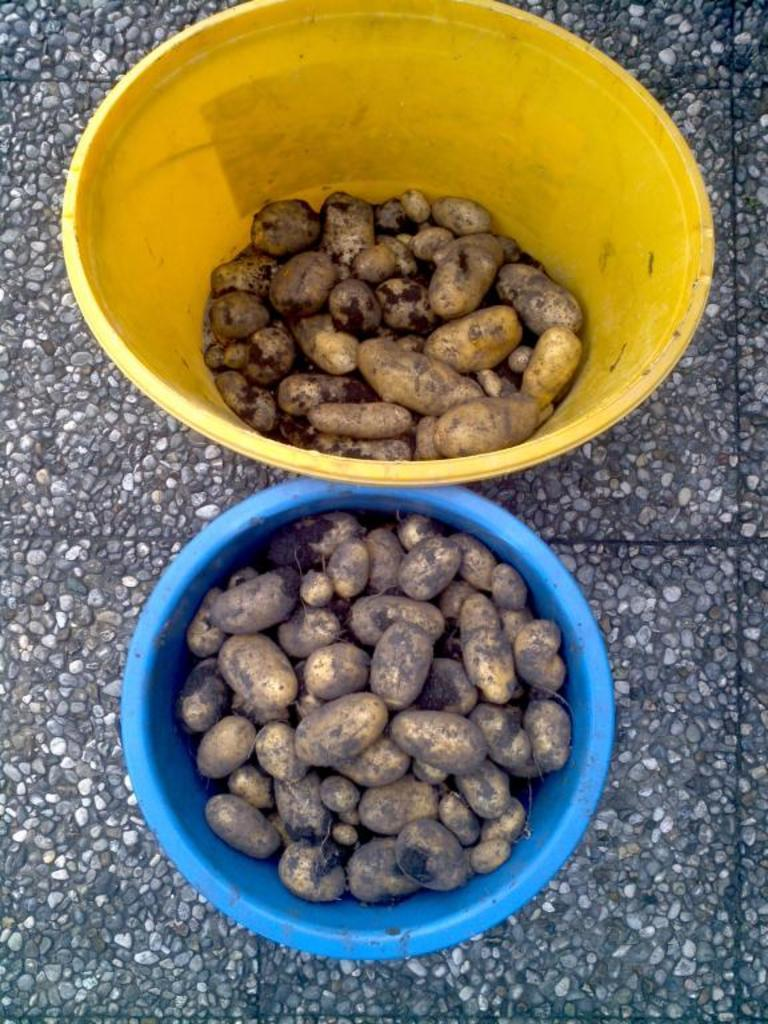What type of food is in the bowls in the image? There are peanuts in two bowls in the image. Can you describe the ground visible in the image? The ground is visible in the image, but no specific details about its appearance are provided. What is the reaction of the crowd to the shocking event in the image? There is no crowd or shocking event present in the image; it only features peanuts in two bowls and the ground. 